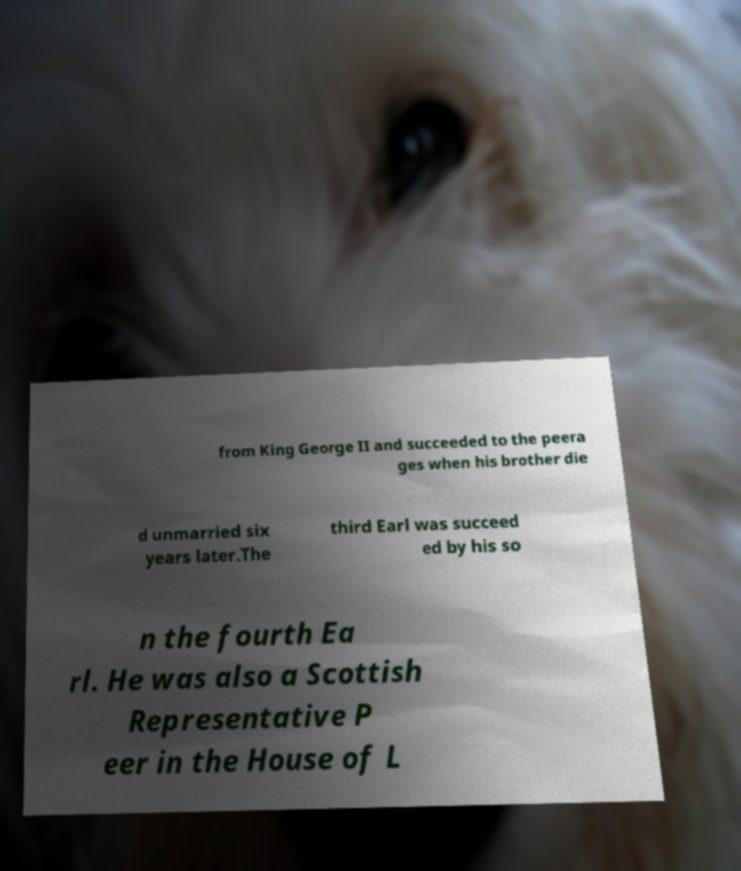Could you extract and type out the text from this image? from King George II and succeeded to the peera ges when his brother die d unmarried six years later.The third Earl was succeed ed by his so n the fourth Ea rl. He was also a Scottish Representative P eer in the House of L 